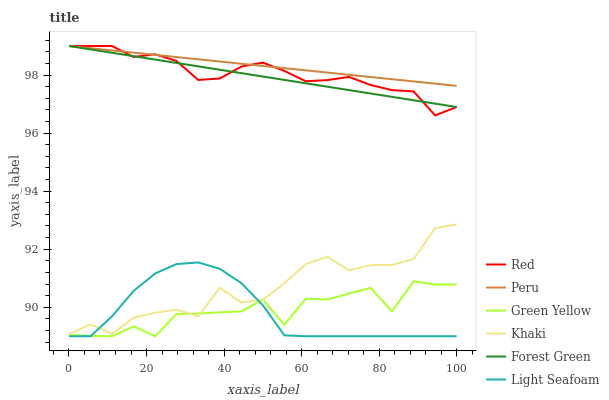Does Light Seafoam have the minimum area under the curve?
Answer yes or no. Yes. Does Peru have the maximum area under the curve?
Answer yes or no. Yes. Does Forest Green have the minimum area under the curve?
Answer yes or no. No. Does Forest Green have the maximum area under the curve?
Answer yes or no. No. Is Peru the smoothest?
Answer yes or no. Yes. Is Green Yellow the roughest?
Answer yes or no. Yes. Is Forest Green the smoothest?
Answer yes or no. No. Is Forest Green the roughest?
Answer yes or no. No. Does Green Yellow have the lowest value?
Answer yes or no. Yes. Does Forest Green have the lowest value?
Answer yes or no. No. Does Red have the highest value?
Answer yes or no. Yes. Does Khaki have the highest value?
Answer yes or no. No. Is Green Yellow less than Peru?
Answer yes or no. Yes. Is Forest Green greater than Light Seafoam?
Answer yes or no. Yes. Does Peru intersect Red?
Answer yes or no. Yes. Is Peru less than Red?
Answer yes or no. No. Is Peru greater than Red?
Answer yes or no. No. Does Green Yellow intersect Peru?
Answer yes or no. No. 